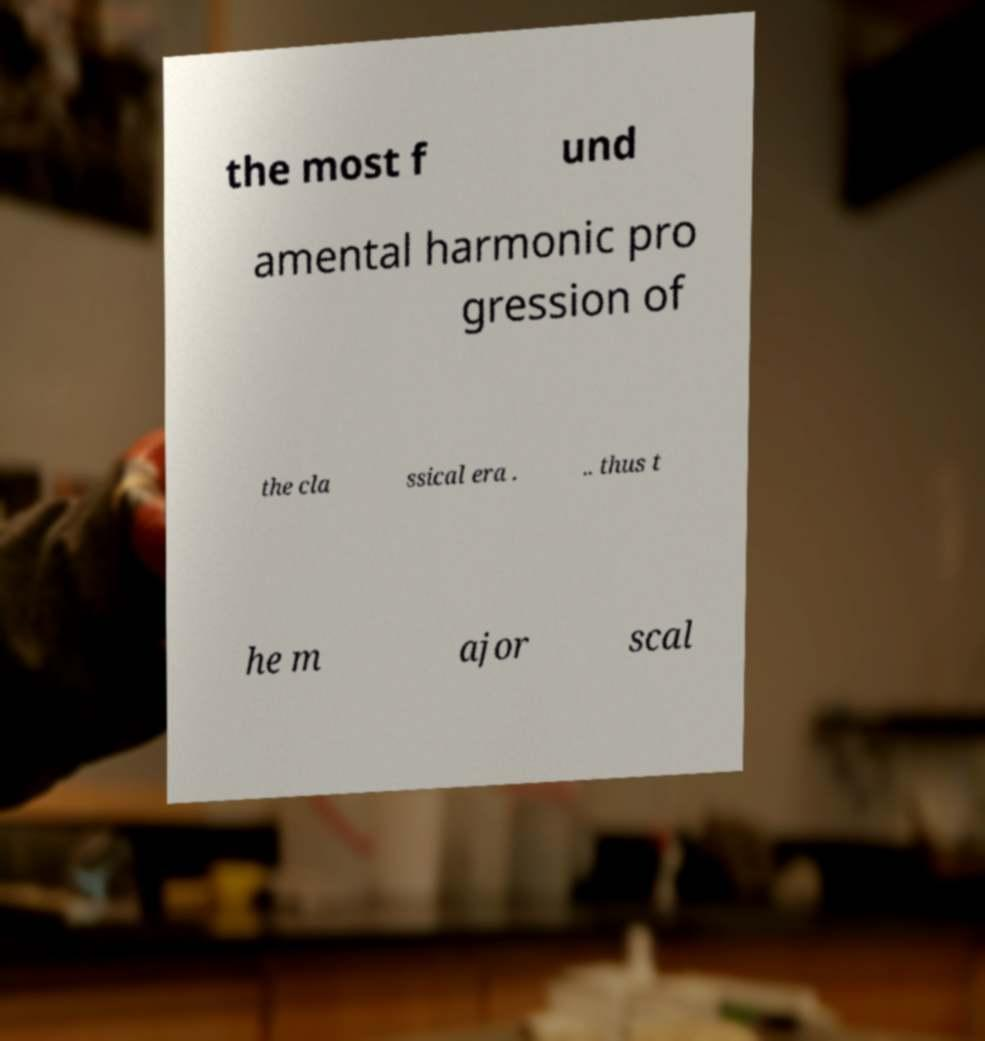Can you read and provide the text displayed in the image?This photo seems to have some interesting text. Can you extract and type it out for me? the most f und amental harmonic pro gression of the cla ssical era . .. thus t he m ajor scal 